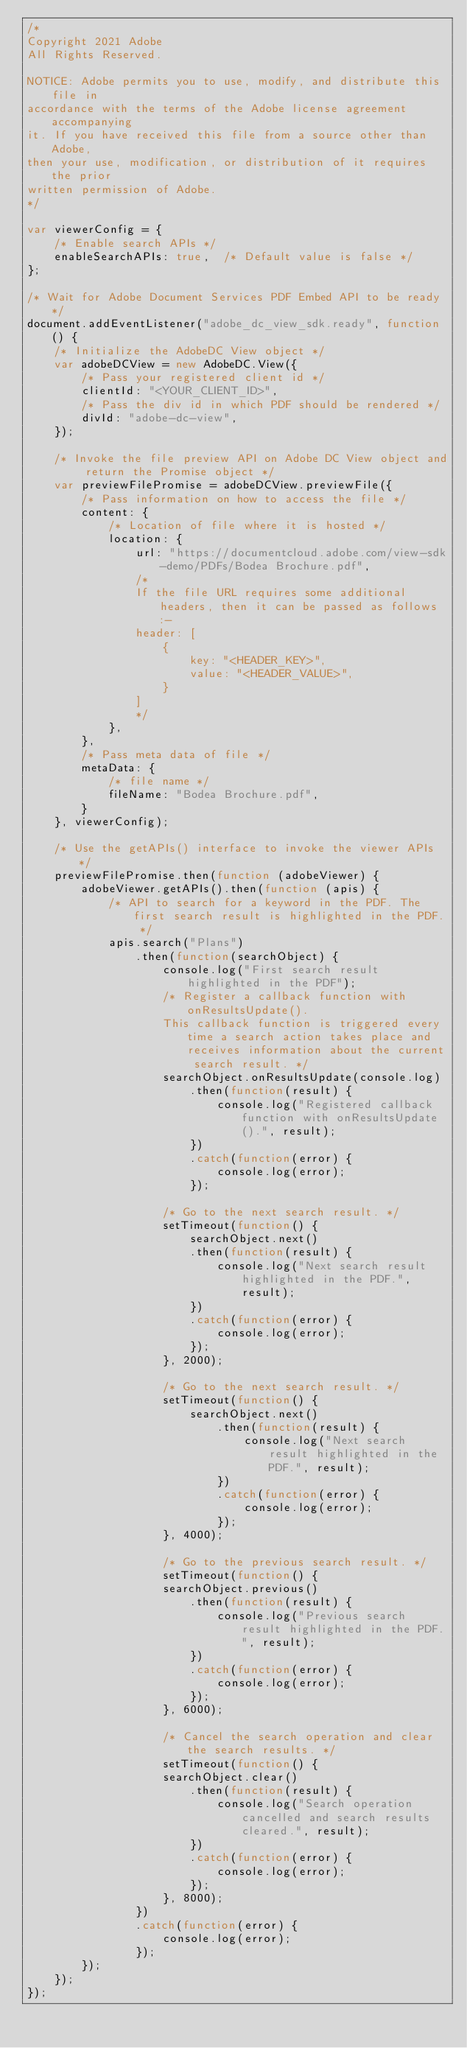<code> <loc_0><loc_0><loc_500><loc_500><_JavaScript_>/*
Copyright 2021 Adobe
All Rights Reserved.

NOTICE: Adobe permits you to use, modify, and distribute this file in
accordance with the terms of the Adobe license agreement accompanying
it. If you have received this file from a source other than Adobe,
then your use, modification, or distribution of it requires the prior
written permission of Adobe.
*/

var viewerConfig = {
    /* Enable search APIs */
    enableSearchAPIs: true,  /* Default value is false */
};

/* Wait for Adobe Document Services PDF Embed API to be ready */
document.addEventListener("adobe_dc_view_sdk.ready", function () {
    /* Initialize the AdobeDC View object */
    var adobeDCView = new AdobeDC.View({
        /* Pass your registered client id */
        clientId: "<YOUR_CLIENT_ID>",
        /* Pass the div id in which PDF should be rendered */
        divId: "adobe-dc-view",
    });

    /* Invoke the file preview API on Adobe DC View object and return the Promise object */
    var previewFilePromise = adobeDCView.previewFile({
        /* Pass information on how to access the file */
        content: {
            /* Location of file where it is hosted */
            location: {
                url: "https://documentcloud.adobe.com/view-sdk-demo/PDFs/Bodea Brochure.pdf",
                /*
                If the file URL requires some additional headers, then it can be passed as follows:-
                header: [
                    {
                        key: "<HEADER_KEY>",
                        value: "<HEADER_VALUE>",
                    }
                ]
                */
            },
        },
        /* Pass meta data of file */
        metaData: {
            /* file name */
            fileName: "Bodea Brochure.pdf",
        }
    }, viewerConfig);

    /* Use the getAPIs() interface to invoke the viewer APIs */
    previewFilePromise.then(function (adobeViewer) {
        adobeViewer.getAPIs().then(function (apis) {
            /* API to search for a keyword in the PDF. The first search result is highlighted in the PDF. */
            apis.search("Plans")
                .then(function(searchObject) {
                    console.log("First search result highlighted in the PDF");
                    /* Register a callback function with onResultsUpdate(). 
                    This callback function is triggered every time a search action takes place and receives information about the current search result. */
                    searchObject.onResultsUpdate(console.log)
                        .then(function(result) {
                            console.log("Registered callback function with onResultsUpdate().", result);
                        })
                        .catch(function(error) {
                            console.log(error);
                        });
                    
                    /* Go to the next search result. */
                    setTimeout(function() {
                        searchObject.next()
                        .then(function(result) {
                            console.log("Next search result highlighted in the PDF.", result);
                        })
                        .catch(function(error) {
                            console.log(error);
                        });
                    }, 2000);
                    
                    /* Go to the next search result. */
                    setTimeout(function() {
                        searchObject.next()
                            .then(function(result) {
                                console.log("Next search result highlighted in the PDF.", result);
                            })
                            .catch(function(error) {
                                console.log(error);
                            });
                    }, 4000);
                    
                    /* Go to the previous search result. */
                    setTimeout(function() {
                    searchObject.previous()
                        .then(function(result) {
                            console.log("Previous search result highlighted in the PDF.", result);
                        })
                        .catch(function(error) {
                            console.log(error);
                        });
                    }, 6000);

                    /* Cancel the search operation and clear the search results. */
                    setTimeout(function() {
                    searchObject.clear()
                        .then(function(result) {
                            console.log("Search operation cancelled and search results cleared.", result);
                        })
                        .catch(function(error) {
                            console.log(error);
                        });
                    }, 8000);
                })
                .catch(function(error) {
                    console.log(error);
                });
        });
    });
});
</code> 